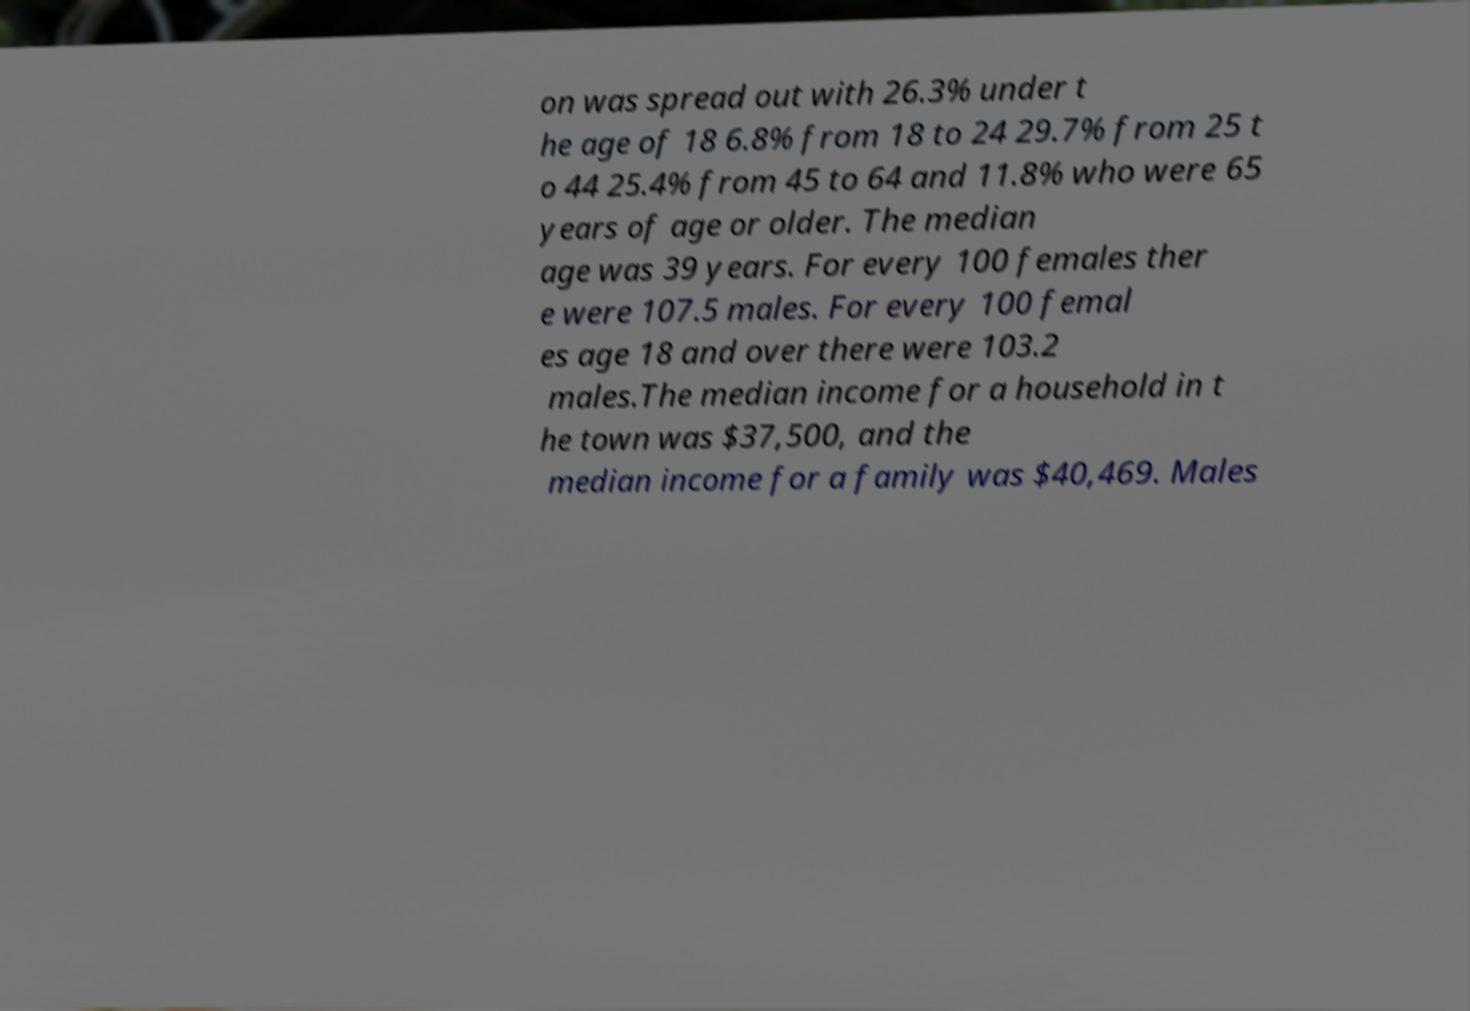There's text embedded in this image that I need extracted. Can you transcribe it verbatim? on was spread out with 26.3% under t he age of 18 6.8% from 18 to 24 29.7% from 25 t o 44 25.4% from 45 to 64 and 11.8% who were 65 years of age or older. The median age was 39 years. For every 100 females ther e were 107.5 males. For every 100 femal es age 18 and over there were 103.2 males.The median income for a household in t he town was $37,500, and the median income for a family was $40,469. Males 